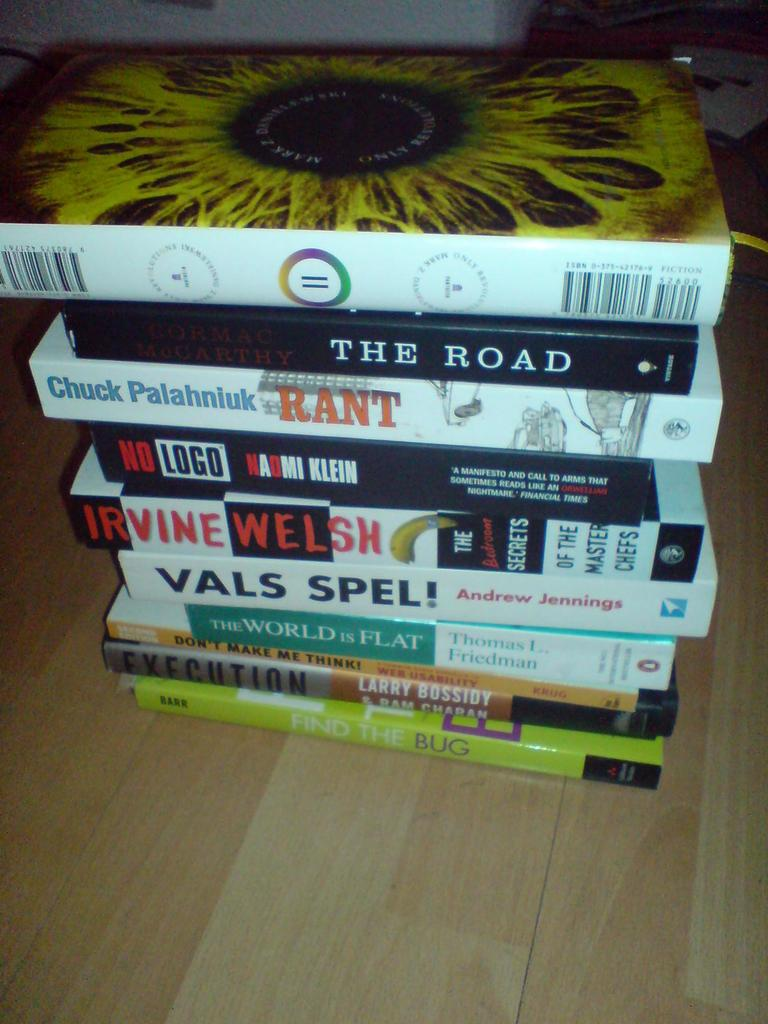<image>
Provide a brief description of the given image. Books are stacked in a pile, the one on the bottom is titled Find the Bug. 